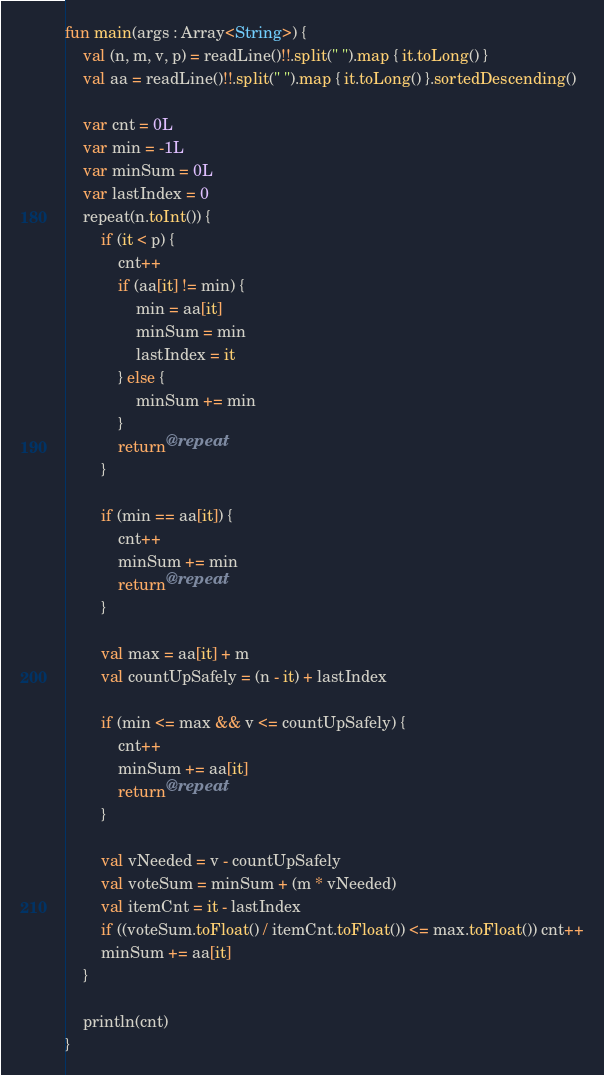<code> <loc_0><loc_0><loc_500><loc_500><_Kotlin_>fun main(args : Array<String>) {
    val (n, m, v, p) = readLine()!!.split(" ").map { it.toLong() }
    val aa = readLine()!!.split(" ").map { it.toLong() }.sortedDescending()

    var cnt = 0L
    var min = -1L
    var minSum = 0L
    var lastIndex = 0
    repeat(n.toInt()) {
        if (it < p) {
            cnt++
            if (aa[it] != min) {
                min = aa[it]
                minSum = min
                lastIndex = it
            } else {
                minSum += min
            }
            return@repeat
        }

        if (min == aa[it]) {
            cnt++
            minSum += min
            return@repeat
        }

        val max = aa[it] + m
        val countUpSafely = (n - it) + lastIndex

        if (min <= max && v <= countUpSafely) {
            cnt++
            minSum += aa[it]
            return@repeat
        }

        val vNeeded = v - countUpSafely
        val voteSum = minSum + (m * vNeeded)
        val itemCnt = it - lastIndex
        if ((voteSum.toFloat() / itemCnt.toFloat()) <= max.toFloat()) cnt++
        minSum += aa[it]
    }

    println(cnt)
}</code> 